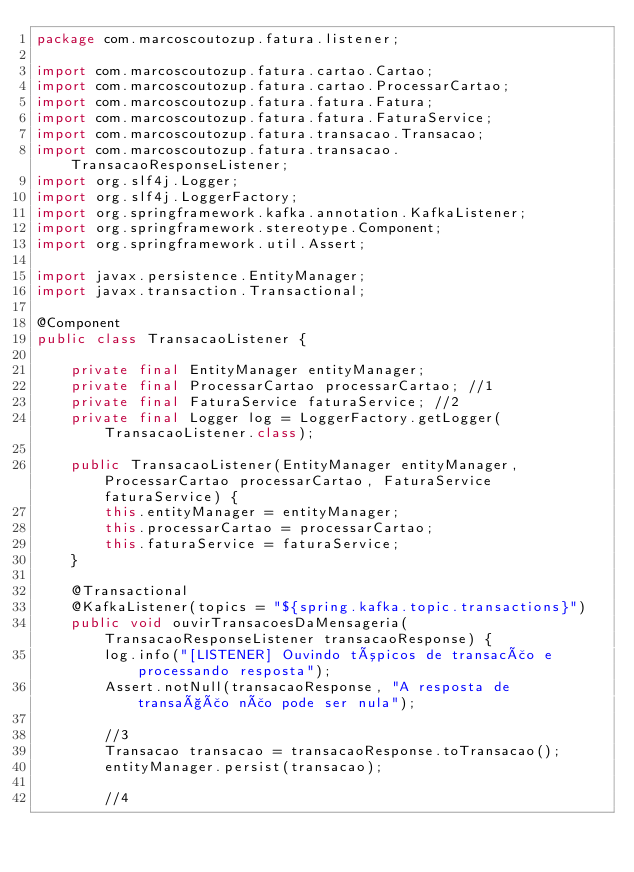Convert code to text. <code><loc_0><loc_0><loc_500><loc_500><_Java_>package com.marcoscoutozup.fatura.listener;

import com.marcoscoutozup.fatura.cartao.Cartao;
import com.marcoscoutozup.fatura.cartao.ProcessarCartao;
import com.marcoscoutozup.fatura.fatura.Fatura;
import com.marcoscoutozup.fatura.fatura.FaturaService;
import com.marcoscoutozup.fatura.transacao.Transacao;
import com.marcoscoutozup.fatura.transacao.TransacaoResponseListener;
import org.slf4j.Logger;
import org.slf4j.LoggerFactory;
import org.springframework.kafka.annotation.KafkaListener;
import org.springframework.stereotype.Component;
import org.springframework.util.Assert;

import javax.persistence.EntityManager;
import javax.transaction.Transactional;

@Component
public class TransacaoListener {

    private final EntityManager entityManager;
    private final ProcessarCartao processarCartao; //1
    private final FaturaService faturaService; //2
    private final Logger log = LoggerFactory.getLogger(TransacaoListener.class);

    public TransacaoListener(EntityManager entityManager, ProcessarCartao processarCartao, FaturaService faturaService) {
        this.entityManager = entityManager;
        this.processarCartao = processarCartao;
        this.faturaService = faturaService;
    }

    @Transactional
    @KafkaListener(topics = "${spring.kafka.topic.transactions}")
    public void ouvirTransacoesDaMensageria(TransacaoResponseListener transacaoResponse) {
        log.info("[LISTENER] Ouvindo tópicos de transacão e processando resposta");
        Assert.notNull(transacaoResponse, "A resposta de transação não pode ser nula");

        //3
        Transacao transacao = transacaoResponse.toTransacao();
        entityManager.persist(transacao);

        //4</code> 